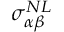Convert formula to latex. <formula><loc_0><loc_0><loc_500><loc_500>\sigma _ { \alpha \beta } ^ { N L }</formula> 